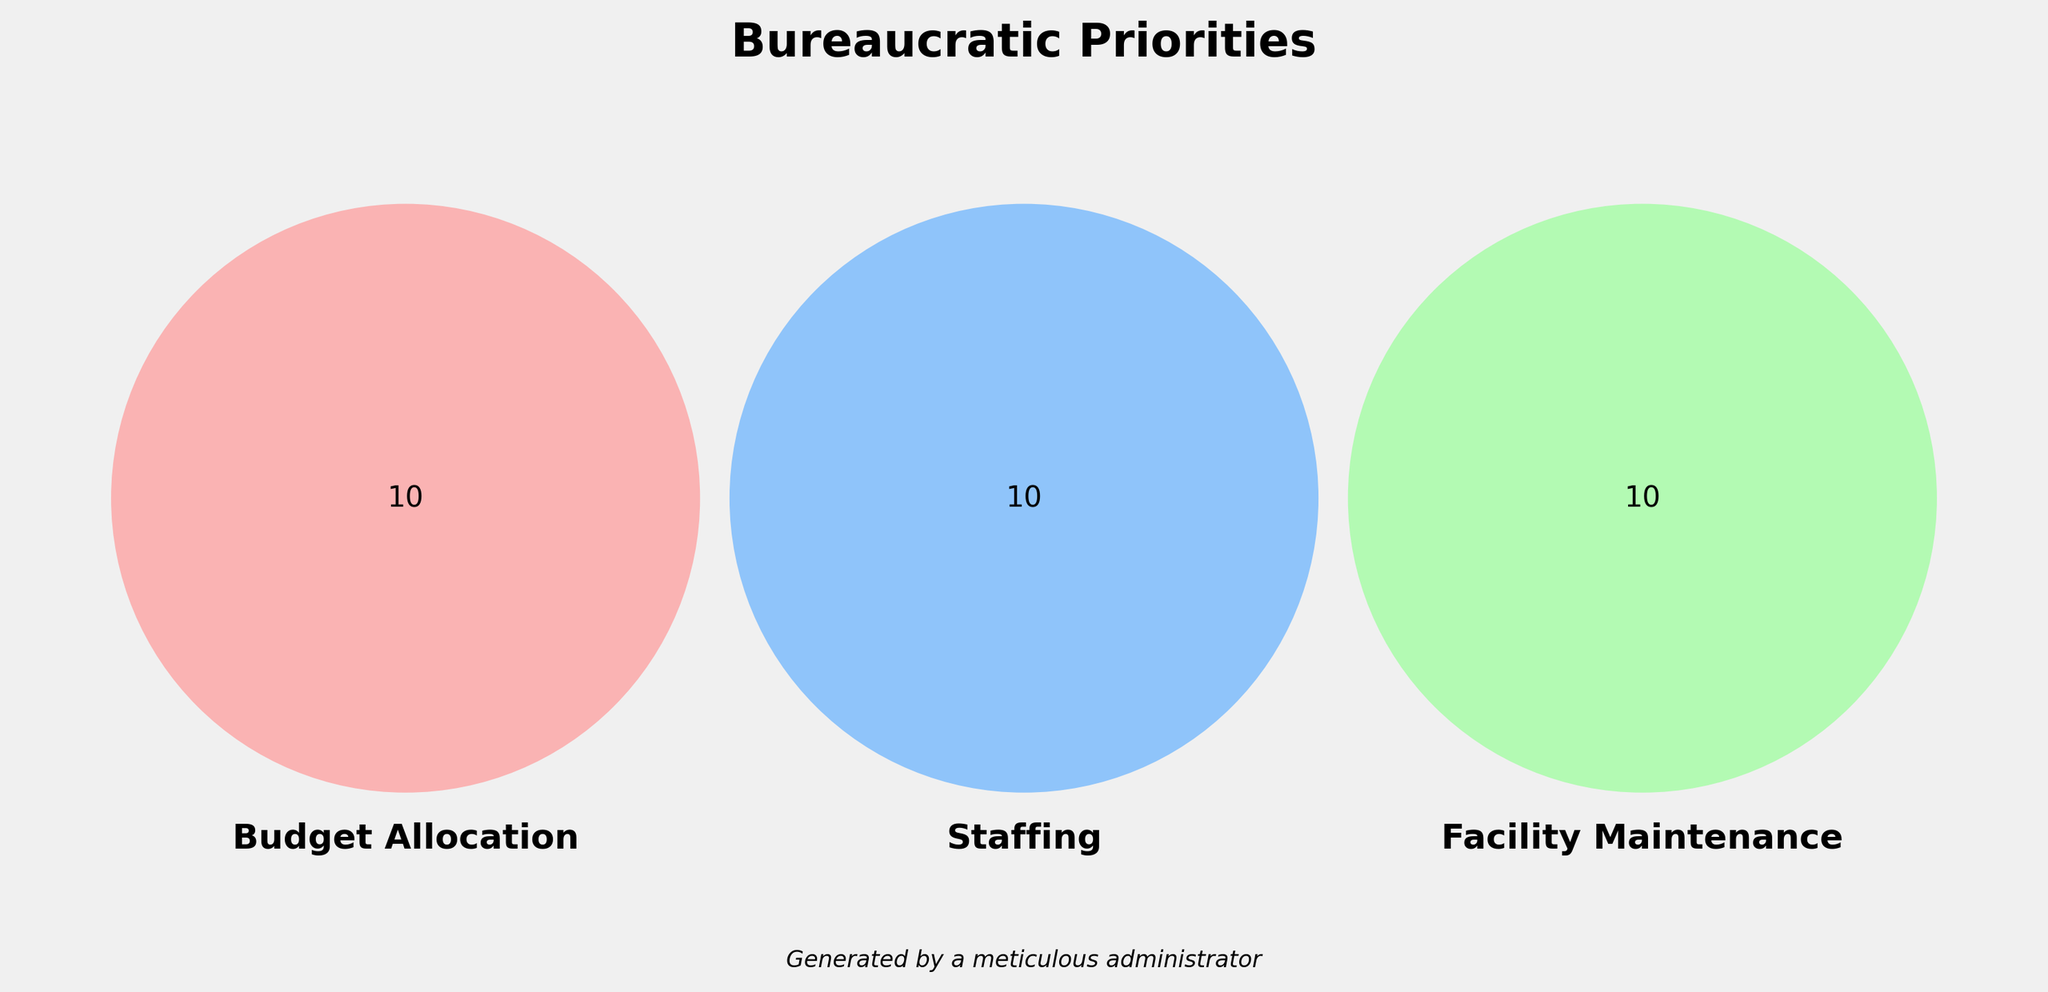What are the three main categories displayed in the Venn Diagram? The Venn Diagram showcases three main categories with set labels: Budget Allocation, Staffing, and Facility Maintenance.
Answer: Budget Allocation, Staffing, Facility Maintenance Which category has a unique color combination only assigned to it? Budget Allocation is represented by a unique light red color, Staffing by a light blue color, and Facility Maintenance by a light green color.
Answer: Each category has its own color How many items fall uniquely under the Budget Allocation section? The Budget Allocation section contains five unique items: Forms & Reports, Expense Tracking, Annual Audits, Grant Applications, and Budget Hearings.
Answer: 5 Do any items overlap between Budget Allocation and Staffing, but not Facility Maintenance? By looking at the visual overlaps in the Venn Diagram, no items are shared between Budget Allocation and Staffing only.
Answer: No Which two categories have the intersection with the highest number of items? By analyzing the Venn Diagram, we can see that each intersection between two categories holds no items, indicating there are no intersections with the highest number of items among two categories.
Answer: None How many total items are listed under all three main categories combined? Adding the unique values for Budget Allocation (5), Staffing (5), and Facility Maintenance (5), we get a total number of items.
Answer: 15 Are there any items that appear in all three categories: Budget Allocation, Staffing, and Facility Maintenance? There are no items at the central intersection of the three circles, which represents items common to all three categories.
Answer: No Which category overlaps with Budget Allocation and Facility Maintenance but not Staffing? By referring to the Venn Diagram, no items are shared between Budget Allocation and Facility Maintenance without intersecting with Staffing.
Answer: None How many items are shared between Staffing and Facility Maintenance without including Budget Allocation? There are no items that intersect between Staffing and Facility Maintenance alone on the Venn Diagram.
Answer: 0 What is the total number of distinct items shared across any two or more categories? Since there are no items shared across any two categories or among all three, the total number from intersections is 0.
Answer: 0 